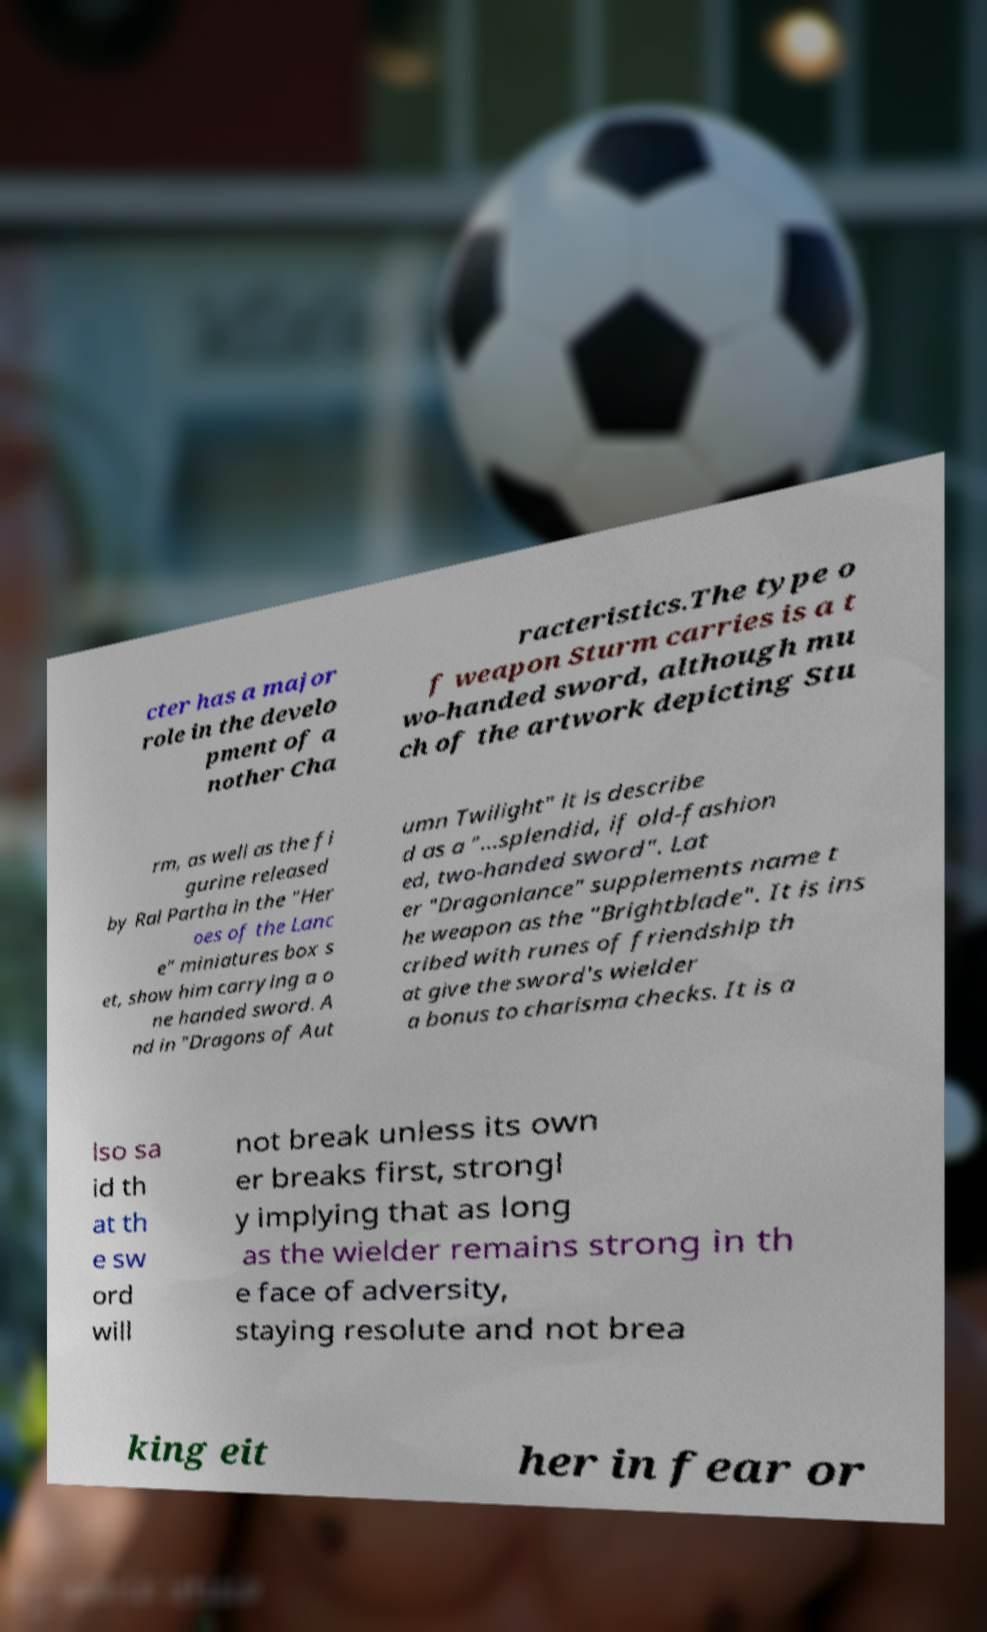Could you assist in decoding the text presented in this image and type it out clearly? cter has a major role in the develo pment of a nother Cha racteristics.The type o f weapon Sturm carries is a t wo-handed sword, although mu ch of the artwork depicting Stu rm, as well as the fi gurine released by Ral Partha in the "Her oes of the Lanc e" miniatures box s et, show him carrying a o ne handed sword. A nd in "Dragons of Aut umn Twilight" it is describe d as a "...splendid, if old-fashion ed, two-handed sword". Lat er "Dragonlance" supplements name t he weapon as the "Brightblade". It is ins cribed with runes of friendship th at give the sword's wielder a bonus to charisma checks. It is a lso sa id th at th e sw ord will not break unless its own er breaks first, strongl y implying that as long as the wielder remains strong in th e face of adversity, staying resolute and not brea king eit her in fear or 